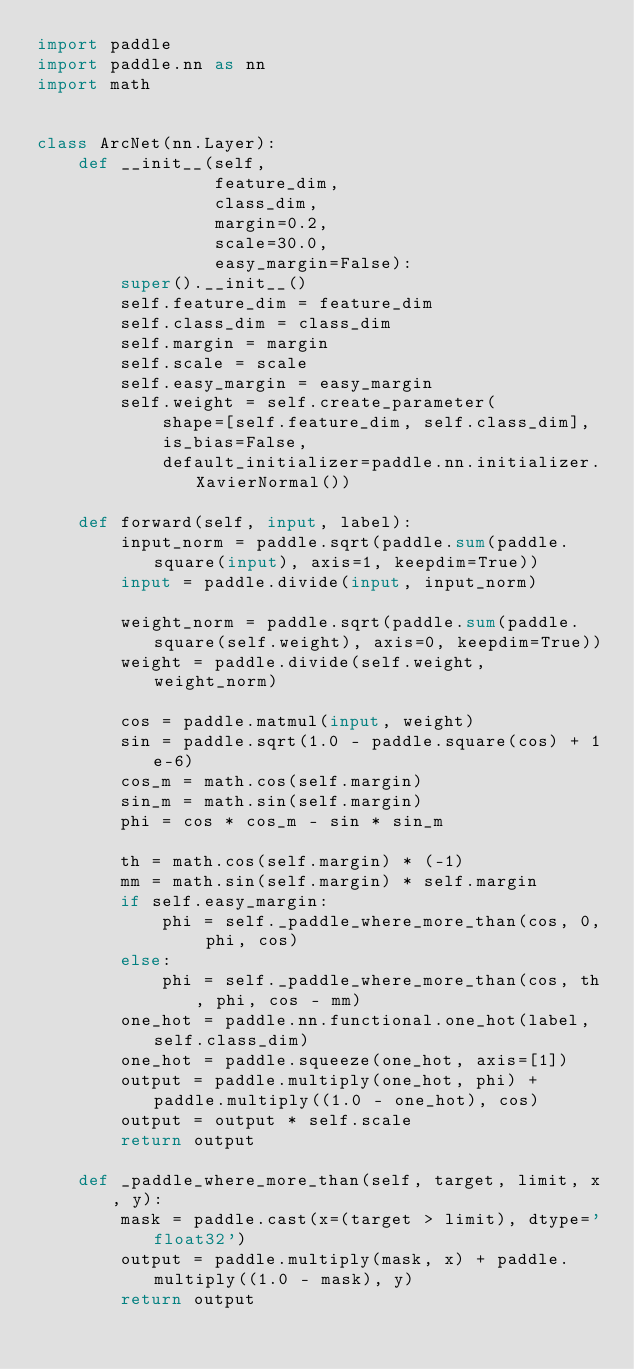<code> <loc_0><loc_0><loc_500><loc_500><_Python_>import paddle
import paddle.nn as nn
import math


class ArcNet(nn.Layer):
    def __init__(self,
                 feature_dim,
                 class_dim,
                 margin=0.2,
                 scale=30.0,
                 easy_margin=False):
        super().__init__()
        self.feature_dim = feature_dim
        self.class_dim = class_dim
        self.margin = margin
        self.scale = scale
        self.easy_margin = easy_margin
        self.weight = self.create_parameter(
            shape=[self.feature_dim, self.class_dim],
            is_bias=False,
            default_initializer=paddle.nn.initializer.XavierNormal())

    def forward(self, input, label):
        input_norm = paddle.sqrt(paddle.sum(paddle.square(input), axis=1, keepdim=True))
        input = paddle.divide(input, input_norm)

        weight_norm = paddle.sqrt(paddle.sum(paddle.square(self.weight), axis=0, keepdim=True))
        weight = paddle.divide(self.weight, weight_norm)

        cos = paddle.matmul(input, weight)
        sin = paddle.sqrt(1.0 - paddle.square(cos) + 1e-6)
        cos_m = math.cos(self.margin)
        sin_m = math.sin(self.margin)
        phi = cos * cos_m - sin * sin_m

        th = math.cos(self.margin) * (-1)
        mm = math.sin(self.margin) * self.margin
        if self.easy_margin:
            phi = self._paddle_where_more_than(cos, 0, phi, cos)
        else:
            phi = self._paddle_where_more_than(cos, th, phi, cos - mm)
        one_hot = paddle.nn.functional.one_hot(label, self.class_dim)
        one_hot = paddle.squeeze(one_hot, axis=[1])
        output = paddle.multiply(one_hot, phi) + paddle.multiply((1.0 - one_hot), cos)
        output = output * self.scale
        return output

    def _paddle_where_more_than(self, target, limit, x, y):
        mask = paddle.cast(x=(target > limit), dtype='float32')
        output = paddle.multiply(mask, x) + paddle.multiply((1.0 - mask), y)
        return output
</code> 